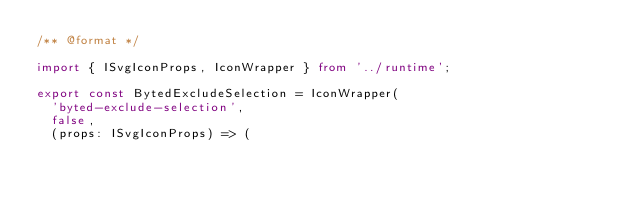<code> <loc_0><loc_0><loc_500><loc_500><_TypeScript_>/** @format */

import { ISvgIconProps, IconWrapper } from '../runtime';

export const BytedExcludeSelection = IconWrapper(
  'byted-exclude-selection',
  false,
  (props: ISvgIconProps) => (</code> 